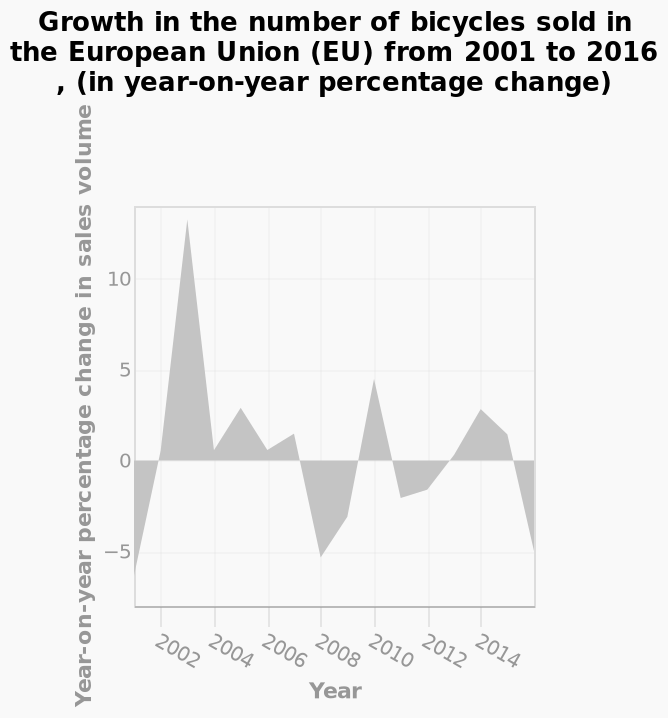<image>
Describe the following image in detail Here a is a area diagram named Growth in the number of bicycles sold in the European Union (EU) from 2001 to 2016 , (in year-on-year percentage change). Year-on-year percentage change in sales volume is drawn on the y-axis. The x-axis measures Year as a linear scale of range 2002 to 2014. 